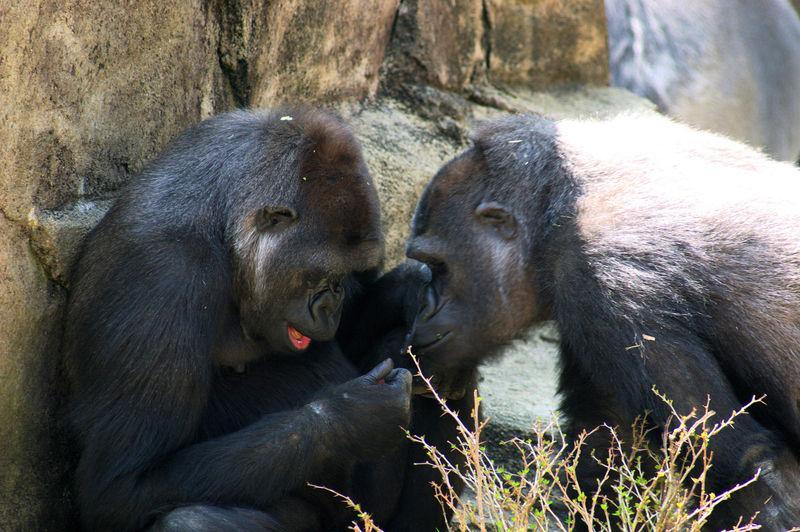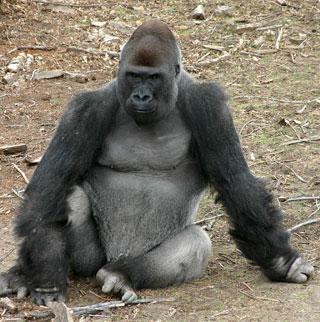The first image is the image on the left, the second image is the image on the right. Analyze the images presented: Is the assertion "An image shows a baby gorilla on the right and one adult gorilla, which is sitting on the left." valid? Answer yes or no. No. The first image is the image on the left, the second image is the image on the right. Analyze the images presented: Is the assertion "One of the images shows exactly one adult gorilla and one baby gorilla in close proximity." valid? Answer yes or no. No. 